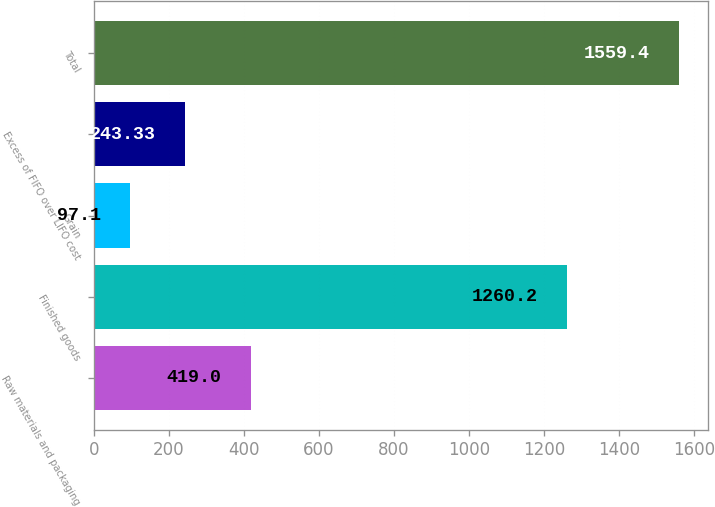<chart> <loc_0><loc_0><loc_500><loc_500><bar_chart><fcel>Raw materials and packaging<fcel>Finished goods<fcel>Grain<fcel>Excess of FIFO over LIFO cost<fcel>Total<nl><fcel>419<fcel>1260.2<fcel>97.1<fcel>243.33<fcel>1559.4<nl></chart> 